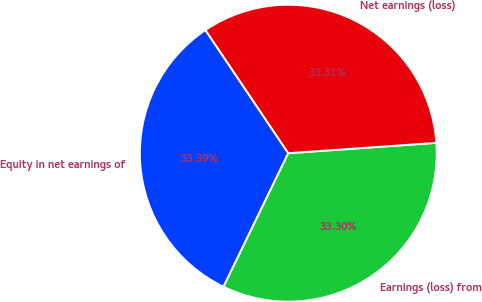Convert chart. <chart><loc_0><loc_0><loc_500><loc_500><pie_chart><fcel>Equity in net earnings of<fcel>Earnings (loss) from<fcel>Net earnings (loss)<nl><fcel>33.39%<fcel>33.3%<fcel>33.31%<nl></chart> 